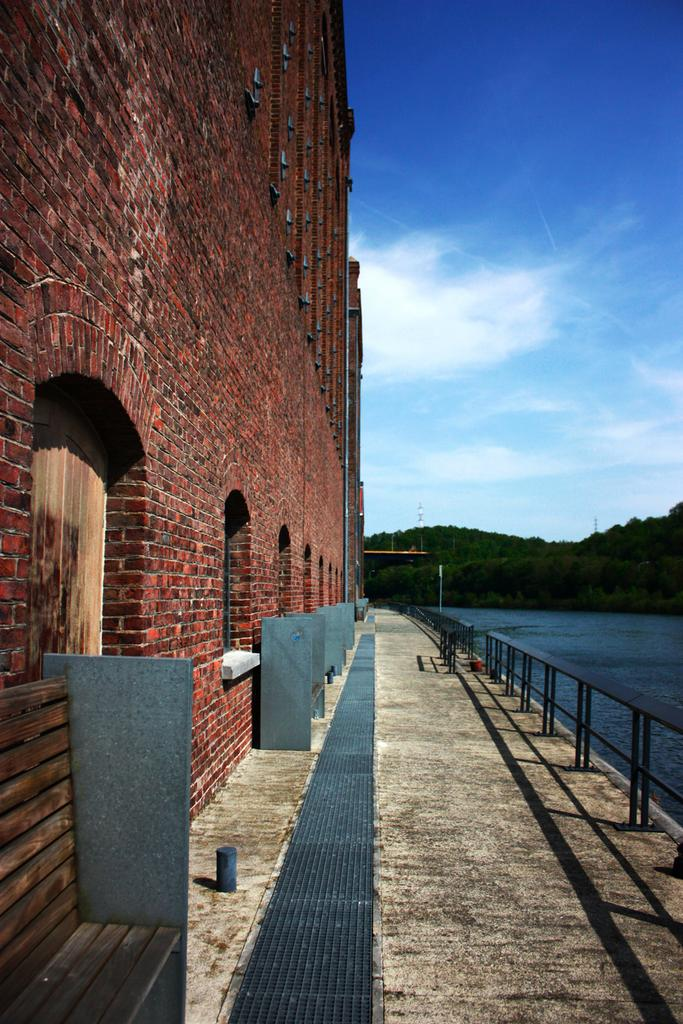What type of structure can be seen in the image? There is a building in the image. What safety feature is present in the image? Railings are present in the image. What infrastructure elements are visible in the image? Pipelines are visible in the image. What natural element can be seen in the image? There is water visible in the image. What type of vegetation is present in the image? Trees are present in the image. What part of the natural environment is visible in the image? The sky is visible in the image. What atmospheric conditions can be observed in the sky? Clouds are present in the sky. What type of behavior is exhibited by the lunch in the image? There is no lunch present in the image, so it is not possible to determine any behavior. 